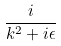Convert formula to latex. <formula><loc_0><loc_0><loc_500><loc_500>\frac { i } { k ^ { 2 } + i \epsilon }</formula> 